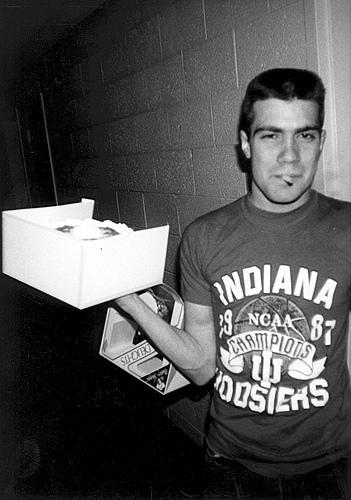Question: what kind of photo is this?
Choices:
A. Black and white.
B. Color.
C. Panaramic.
D. 3-d.
Answer with the letter. Answer: A Question: when was this photo taken?
Choices:
A. While the man was holding the box.
B. When the woman was getting on the elevator.
C. While the man was working at his desk.
D. While the woman was talking on the phone.
Answer with the letter. Answer: A Question: what date is on the man's shirt?
Choices:
A. 1992.
B. 1987.
C. 1979.
D. 1959.
Answer with the letter. Answer: B Question: why was this photo taken?
Choices:
A. For the wedding album.
B. To show the man.
C. For the child's scrapbook.
D. To capture all the birthday presents.
Answer with the letter. Answer: B 